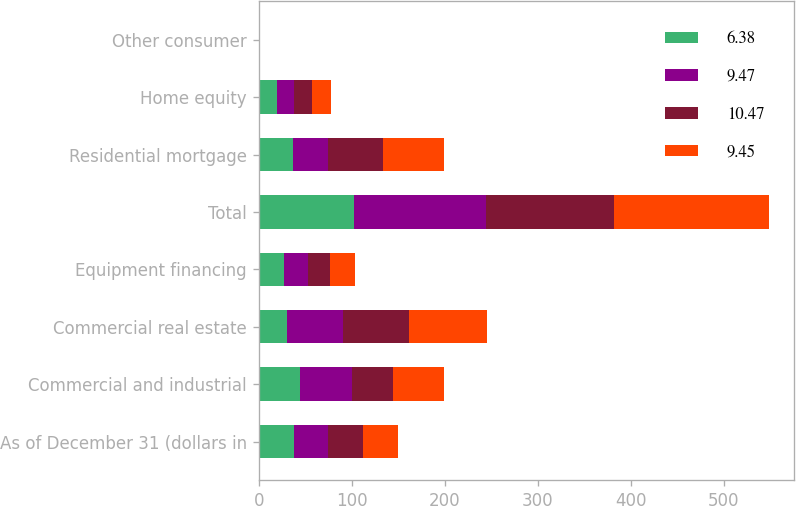<chart> <loc_0><loc_0><loc_500><loc_500><stacked_bar_chart><ecel><fcel>As of December 31 (dollars in<fcel>Commercial and industrial<fcel>Commercial real estate<fcel>Equipment financing<fcel>Total<fcel>Residential mortgage<fcel>Home equity<fcel>Other consumer<nl><fcel>6.38<fcel>37.4<fcel>44.9<fcel>30.2<fcel>27.5<fcel>102.6<fcel>37.2<fcel>19.5<fcel>0.1<nl><fcel>9.47<fcel>37.4<fcel>55.8<fcel>60.2<fcel>25.4<fcel>141.4<fcel>37.6<fcel>17.9<fcel>0.1<nl><fcel>10.47<fcel>37.4<fcel>43.8<fcel>70.8<fcel>23.2<fcel>137.8<fcel>58.9<fcel>19.8<fcel>0.1<nl><fcel>9.45<fcel>37.4<fcel>54.8<fcel>84.4<fcel>27.2<fcel>166.4<fcel>65<fcel>21<fcel>0.3<nl></chart> 